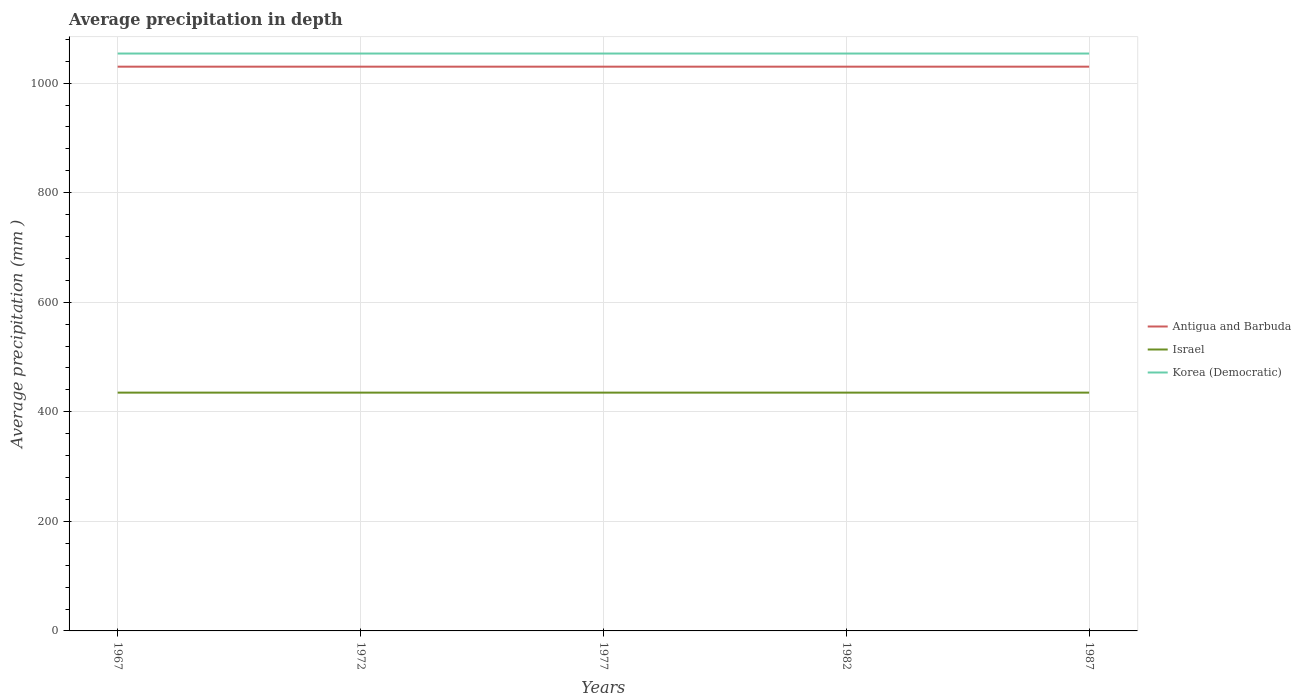How many different coloured lines are there?
Keep it short and to the point. 3. Is the number of lines equal to the number of legend labels?
Your response must be concise. Yes. Across all years, what is the maximum average precipitation in Korea (Democratic)?
Provide a succinct answer. 1054. In which year was the average precipitation in Antigua and Barbuda maximum?
Ensure brevity in your answer.  1967. What is the total average precipitation in Israel in the graph?
Ensure brevity in your answer.  0. What is the difference between the highest and the second highest average precipitation in Korea (Democratic)?
Provide a succinct answer. 0. How many lines are there?
Offer a terse response. 3. How many years are there in the graph?
Provide a succinct answer. 5. Are the values on the major ticks of Y-axis written in scientific E-notation?
Ensure brevity in your answer.  No. Does the graph contain grids?
Your answer should be very brief. Yes. Where does the legend appear in the graph?
Your response must be concise. Center right. How many legend labels are there?
Provide a short and direct response. 3. What is the title of the graph?
Your response must be concise. Average precipitation in depth. What is the label or title of the X-axis?
Your answer should be very brief. Years. What is the label or title of the Y-axis?
Your answer should be very brief. Average precipitation (mm ). What is the Average precipitation (mm ) of Antigua and Barbuda in 1967?
Ensure brevity in your answer.  1030. What is the Average precipitation (mm ) in Israel in 1967?
Offer a terse response. 435. What is the Average precipitation (mm ) in Korea (Democratic) in 1967?
Your answer should be compact. 1054. What is the Average precipitation (mm ) of Antigua and Barbuda in 1972?
Your answer should be compact. 1030. What is the Average precipitation (mm ) of Israel in 1972?
Your answer should be compact. 435. What is the Average precipitation (mm ) in Korea (Democratic) in 1972?
Provide a succinct answer. 1054. What is the Average precipitation (mm ) of Antigua and Barbuda in 1977?
Offer a very short reply. 1030. What is the Average precipitation (mm ) of Israel in 1977?
Offer a terse response. 435. What is the Average precipitation (mm ) of Korea (Democratic) in 1977?
Provide a short and direct response. 1054. What is the Average precipitation (mm ) in Antigua and Barbuda in 1982?
Ensure brevity in your answer.  1030. What is the Average precipitation (mm ) of Israel in 1982?
Your response must be concise. 435. What is the Average precipitation (mm ) of Korea (Democratic) in 1982?
Give a very brief answer. 1054. What is the Average precipitation (mm ) of Antigua and Barbuda in 1987?
Your answer should be very brief. 1030. What is the Average precipitation (mm ) in Israel in 1987?
Keep it short and to the point. 435. What is the Average precipitation (mm ) of Korea (Democratic) in 1987?
Offer a terse response. 1054. Across all years, what is the maximum Average precipitation (mm ) of Antigua and Barbuda?
Provide a short and direct response. 1030. Across all years, what is the maximum Average precipitation (mm ) of Israel?
Keep it short and to the point. 435. Across all years, what is the maximum Average precipitation (mm ) of Korea (Democratic)?
Offer a very short reply. 1054. Across all years, what is the minimum Average precipitation (mm ) of Antigua and Barbuda?
Your response must be concise. 1030. Across all years, what is the minimum Average precipitation (mm ) of Israel?
Your answer should be compact. 435. Across all years, what is the minimum Average precipitation (mm ) in Korea (Democratic)?
Give a very brief answer. 1054. What is the total Average precipitation (mm ) in Antigua and Barbuda in the graph?
Keep it short and to the point. 5150. What is the total Average precipitation (mm ) in Israel in the graph?
Your answer should be very brief. 2175. What is the total Average precipitation (mm ) of Korea (Democratic) in the graph?
Offer a very short reply. 5270. What is the difference between the Average precipitation (mm ) in Antigua and Barbuda in 1967 and that in 1972?
Make the answer very short. 0. What is the difference between the Average precipitation (mm ) of Israel in 1967 and that in 1972?
Make the answer very short. 0. What is the difference between the Average precipitation (mm ) in Korea (Democratic) in 1967 and that in 1972?
Your response must be concise. 0. What is the difference between the Average precipitation (mm ) of Korea (Democratic) in 1967 and that in 1977?
Your response must be concise. 0. What is the difference between the Average precipitation (mm ) of Israel in 1967 and that in 1982?
Offer a terse response. 0. What is the difference between the Average precipitation (mm ) in Korea (Democratic) in 1967 and that in 1987?
Make the answer very short. 0. What is the difference between the Average precipitation (mm ) of Israel in 1972 and that in 1977?
Keep it short and to the point. 0. What is the difference between the Average precipitation (mm ) of Israel in 1972 and that in 1982?
Provide a short and direct response. 0. What is the difference between the Average precipitation (mm ) of Korea (Democratic) in 1972 and that in 1982?
Provide a short and direct response. 0. What is the difference between the Average precipitation (mm ) in Antigua and Barbuda in 1977 and that in 1982?
Offer a very short reply. 0. What is the difference between the Average precipitation (mm ) in Israel in 1977 and that in 1982?
Your answer should be compact. 0. What is the difference between the Average precipitation (mm ) of Korea (Democratic) in 1977 and that in 1982?
Your answer should be very brief. 0. What is the difference between the Average precipitation (mm ) in Antigua and Barbuda in 1977 and that in 1987?
Offer a very short reply. 0. What is the difference between the Average precipitation (mm ) of Korea (Democratic) in 1977 and that in 1987?
Make the answer very short. 0. What is the difference between the Average precipitation (mm ) of Antigua and Barbuda in 1982 and that in 1987?
Provide a short and direct response. 0. What is the difference between the Average precipitation (mm ) in Israel in 1982 and that in 1987?
Offer a terse response. 0. What is the difference between the Average precipitation (mm ) of Antigua and Barbuda in 1967 and the Average precipitation (mm ) of Israel in 1972?
Ensure brevity in your answer.  595. What is the difference between the Average precipitation (mm ) of Antigua and Barbuda in 1967 and the Average precipitation (mm ) of Korea (Democratic) in 1972?
Provide a succinct answer. -24. What is the difference between the Average precipitation (mm ) of Israel in 1967 and the Average precipitation (mm ) of Korea (Democratic) in 1972?
Offer a very short reply. -619. What is the difference between the Average precipitation (mm ) in Antigua and Barbuda in 1967 and the Average precipitation (mm ) in Israel in 1977?
Provide a short and direct response. 595. What is the difference between the Average precipitation (mm ) in Antigua and Barbuda in 1967 and the Average precipitation (mm ) in Korea (Democratic) in 1977?
Ensure brevity in your answer.  -24. What is the difference between the Average precipitation (mm ) in Israel in 1967 and the Average precipitation (mm ) in Korea (Democratic) in 1977?
Provide a succinct answer. -619. What is the difference between the Average precipitation (mm ) in Antigua and Barbuda in 1967 and the Average precipitation (mm ) in Israel in 1982?
Ensure brevity in your answer.  595. What is the difference between the Average precipitation (mm ) of Antigua and Barbuda in 1967 and the Average precipitation (mm ) of Korea (Democratic) in 1982?
Your answer should be very brief. -24. What is the difference between the Average precipitation (mm ) of Israel in 1967 and the Average precipitation (mm ) of Korea (Democratic) in 1982?
Keep it short and to the point. -619. What is the difference between the Average precipitation (mm ) of Antigua and Barbuda in 1967 and the Average precipitation (mm ) of Israel in 1987?
Give a very brief answer. 595. What is the difference between the Average precipitation (mm ) of Antigua and Barbuda in 1967 and the Average precipitation (mm ) of Korea (Democratic) in 1987?
Ensure brevity in your answer.  -24. What is the difference between the Average precipitation (mm ) of Israel in 1967 and the Average precipitation (mm ) of Korea (Democratic) in 1987?
Your response must be concise. -619. What is the difference between the Average precipitation (mm ) of Antigua and Barbuda in 1972 and the Average precipitation (mm ) of Israel in 1977?
Offer a terse response. 595. What is the difference between the Average precipitation (mm ) of Antigua and Barbuda in 1972 and the Average precipitation (mm ) of Korea (Democratic) in 1977?
Your response must be concise. -24. What is the difference between the Average precipitation (mm ) of Israel in 1972 and the Average precipitation (mm ) of Korea (Democratic) in 1977?
Keep it short and to the point. -619. What is the difference between the Average precipitation (mm ) in Antigua and Barbuda in 1972 and the Average precipitation (mm ) in Israel in 1982?
Your response must be concise. 595. What is the difference between the Average precipitation (mm ) in Antigua and Barbuda in 1972 and the Average precipitation (mm ) in Korea (Democratic) in 1982?
Ensure brevity in your answer.  -24. What is the difference between the Average precipitation (mm ) of Israel in 1972 and the Average precipitation (mm ) of Korea (Democratic) in 1982?
Make the answer very short. -619. What is the difference between the Average precipitation (mm ) in Antigua and Barbuda in 1972 and the Average precipitation (mm ) in Israel in 1987?
Give a very brief answer. 595. What is the difference between the Average precipitation (mm ) of Israel in 1972 and the Average precipitation (mm ) of Korea (Democratic) in 1987?
Ensure brevity in your answer.  -619. What is the difference between the Average precipitation (mm ) of Antigua and Barbuda in 1977 and the Average precipitation (mm ) of Israel in 1982?
Provide a short and direct response. 595. What is the difference between the Average precipitation (mm ) of Antigua and Barbuda in 1977 and the Average precipitation (mm ) of Korea (Democratic) in 1982?
Your response must be concise. -24. What is the difference between the Average precipitation (mm ) in Israel in 1977 and the Average precipitation (mm ) in Korea (Democratic) in 1982?
Your response must be concise. -619. What is the difference between the Average precipitation (mm ) of Antigua and Barbuda in 1977 and the Average precipitation (mm ) of Israel in 1987?
Give a very brief answer. 595. What is the difference between the Average precipitation (mm ) in Israel in 1977 and the Average precipitation (mm ) in Korea (Democratic) in 1987?
Offer a terse response. -619. What is the difference between the Average precipitation (mm ) in Antigua and Barbuda in 1982 and the Average precipitation (mm ) in Israel in 1987?
Provide a succinct answer. 595. What is the difference between the Average precipitation (mm ) in Israel in 1982 and the Average precipitation (mm ) in Korea (Democratic) in 1987?
Your answer should be compact. -619. What is the average Average precipitation (mm ) in Antigua and Barbuda per year?
Your answer should be very brief. 1030. What is the average Average precipitation (mm ) of Israel per year?
Provide a short and direct response. 435. What is the average Average precipitation (mm ) in Korea (Democratic) per year?
Your answer should be very brief. 1054. In the year 1967, what is the difference between the Average precipitation (mm ) in Antigua and Barbuda and Average precipitation (mm ) in Israel?
Offer a terse response. 595. In the year 1967, what is the difference between the Average precipitation (mm ) in Antigua and Barbuda and Average precipitation (mm ) in Korea (Democratic)?
Keep it short and to the point. -24. In the year 1967, what is the difference between the Average precipitation (mm ) of Israel and Average precipitation (mm ) of Korea (Democratic)?
Your answer should be compact. -619. In the year 1972, what is the difference between the Average precipitation (mm ) in Antigua and Barbuda and Average precipitation (mm ) in Israel?
Ensure brevity in your answer.  595. In the year 1972, what is the difference between the Average precipitation (mm ) in Antigua and Barbuda and Average precipitation (mm ) in Korea (Democratic)?
Give a very brief answer. -24. In the year 1972, what is the difference between the Average precipitation (mm ) of Israel and Average precipitation (mm ) of Korea (Democratic)?
Keep it short and to the point. -619. In the year 1977, what is the difference between the Average precipitation (mm ) of Antigua and Barbuda and Average precipitation (mm ) of Israel?
Provide a short and direct response. 595. In the year 1977, what is the difference between the Average precipitation (mm ) in Antigua and Barbuda and Average precipitation (mm ) in Korea (Democratic)?
Provide a succinct answer. -24. In the year 1977, what is the difference between the Average precipitation (mm ) of Israel and Average precipitation (mm ) of Korea (Democratic)?
Provide a short and direct response. -619. In the year 1982, what is the difference between the Average precipitation (mm ) in Antigua and Barbuda and Average precipitation (mm ) in Israel?
Make the answer very short. 595. In the year 1982, what is the difference between the Average precipitation (mm ) in Israel and Average precipitation (mm ) in Korea (Democratic)?
Offer a very short reply. -619. In the year 1987, what is the difference between the Average precipitation (mm ) of Antigua and Barbuda and Average precipitation (mm ) of Israel?
Keep it short and to the point. 595. In the year 1987, what is the difference between the Average precipitation (mm ) of Israel and Average precipitation (mm ) of Korea (Democratic)?
Keep it short and to the point. -619. What is the ratio of the Average precipitation (mm ) of Korea (Democratic) in 1967 to that in 1972?
Offer a very short reply. 1. What is the ratio of the Average precipitation (mm ) in Antigua and Barbuda in 1967 to that in 1977?
Offer a very short reply. 1. What is the ratio of the Average precipitation (mm ) in Israel in 1967 to that in 1977?
Your response must be concise. 1. What is the ratio of the Average precipitation (mm ) of Korea (Democratic) in 1967 to that in 1977?
Provide a short and direct response. 1. What is the ratio of the Average precipitation (mm ) of Israel in 1967 to that in 1982?
Your response must be concise. 1. What is the ratio of the Average precipitation (mm ) in Israel in 1967 to that in 1987?
Provide a succinct answer. 1. What is the ratio of the Average precipitation (mm ) of Antigua and Barbuda in 1972 to that in 1977?
Provide a succinct answer. 1. What is the ratio of the Average precipitation (mm ) of Israel in 1972 to that in 1977?
Your answer should be compact. 1. What is the ratio of the Average precipitation (mm ) in Antigua and Barbuda in 1972 to that in 1987?
Offer a very short reply. 1. What is the ratio of the Average precipitation (mm ) in Israel in 1972 to that in 1987?
Give a very brief answer. 1. What is the ratio of the Average precipitation (mm ) in Korea (Democratic) in 1972 to that in 1987?
Give a very brief answer. 1. What is the ratio of the Average precipitation (mm ) in Israel in 1977 to that in 1982?
Provide a short and direct response. 1. What is the ratio of the Average precipitation (mm ) in Korea (Democratic) in 1977 to that in 1982?
Offer a terse response. 1. What is the ratio of the Average precipitation (mm ) of Israel in 1977 to that in 1987?
Make the answer very short. 1. What is the difference between the highest and the second highest Average precipitation (mm ) in Israel?
Offer a terse response. 0. What is the difference between the highest and the lowest Average precipitation (mm ) in Antigua and Barbuda?
Your answer should be very brief. 0. 